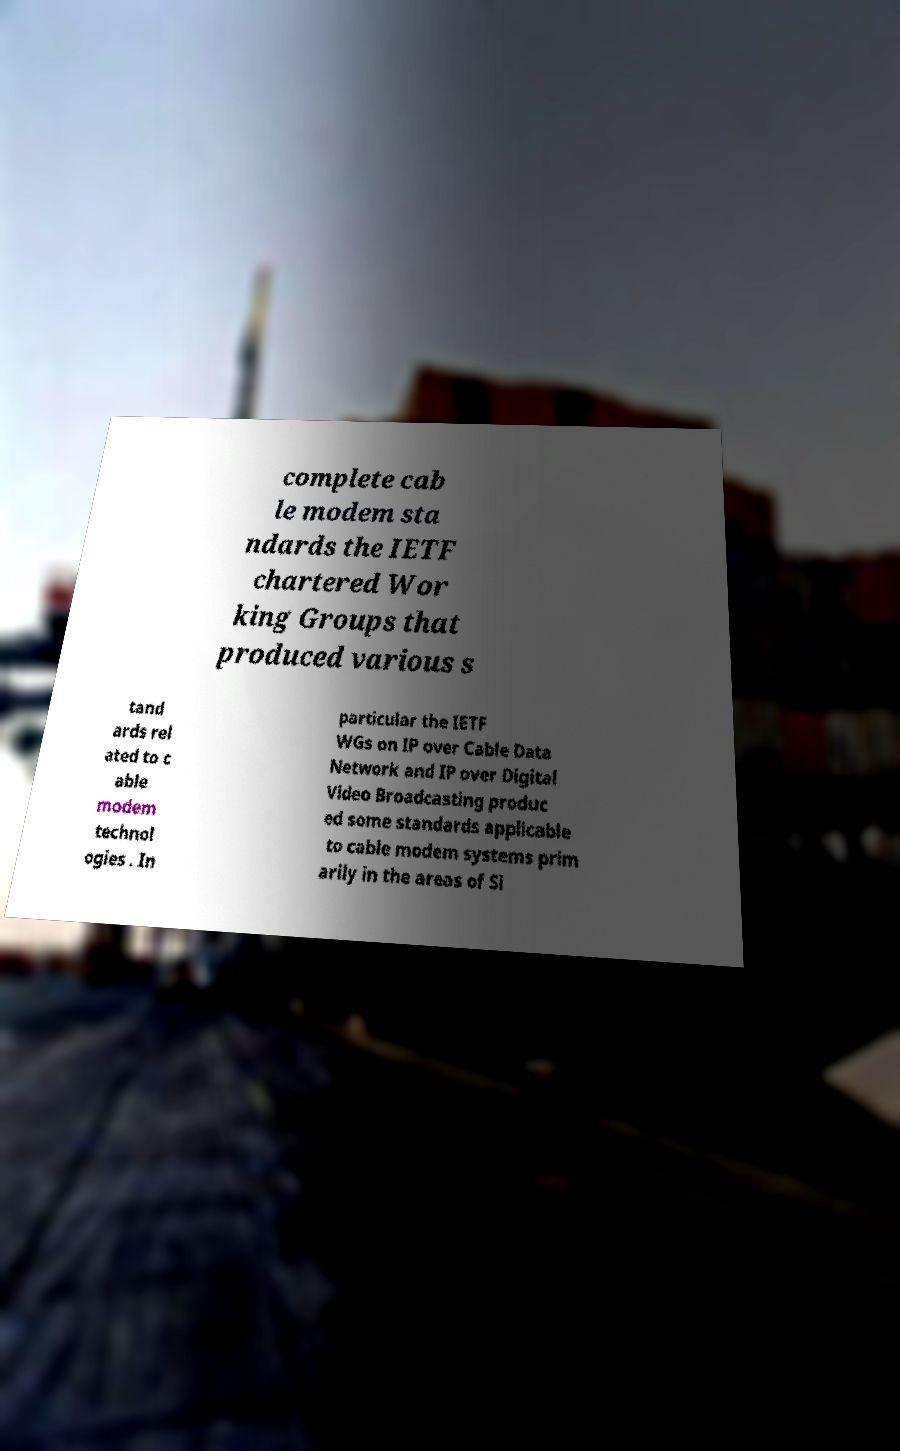Can you read and provide the text displayed in the image?This photo seems to have some interesting text. Can you extract and type it out for me? complete cab le modem sta ndards the IETF chartered Wor king Groups that produced various s tand ards rel ated to c able modem technol ogies . In particular the IETF WGs on IP over Cable Data Network and IP over Digital Video Broadcasting produc ed some standards applicable to cable modem systems prim arily in the areas of Si 